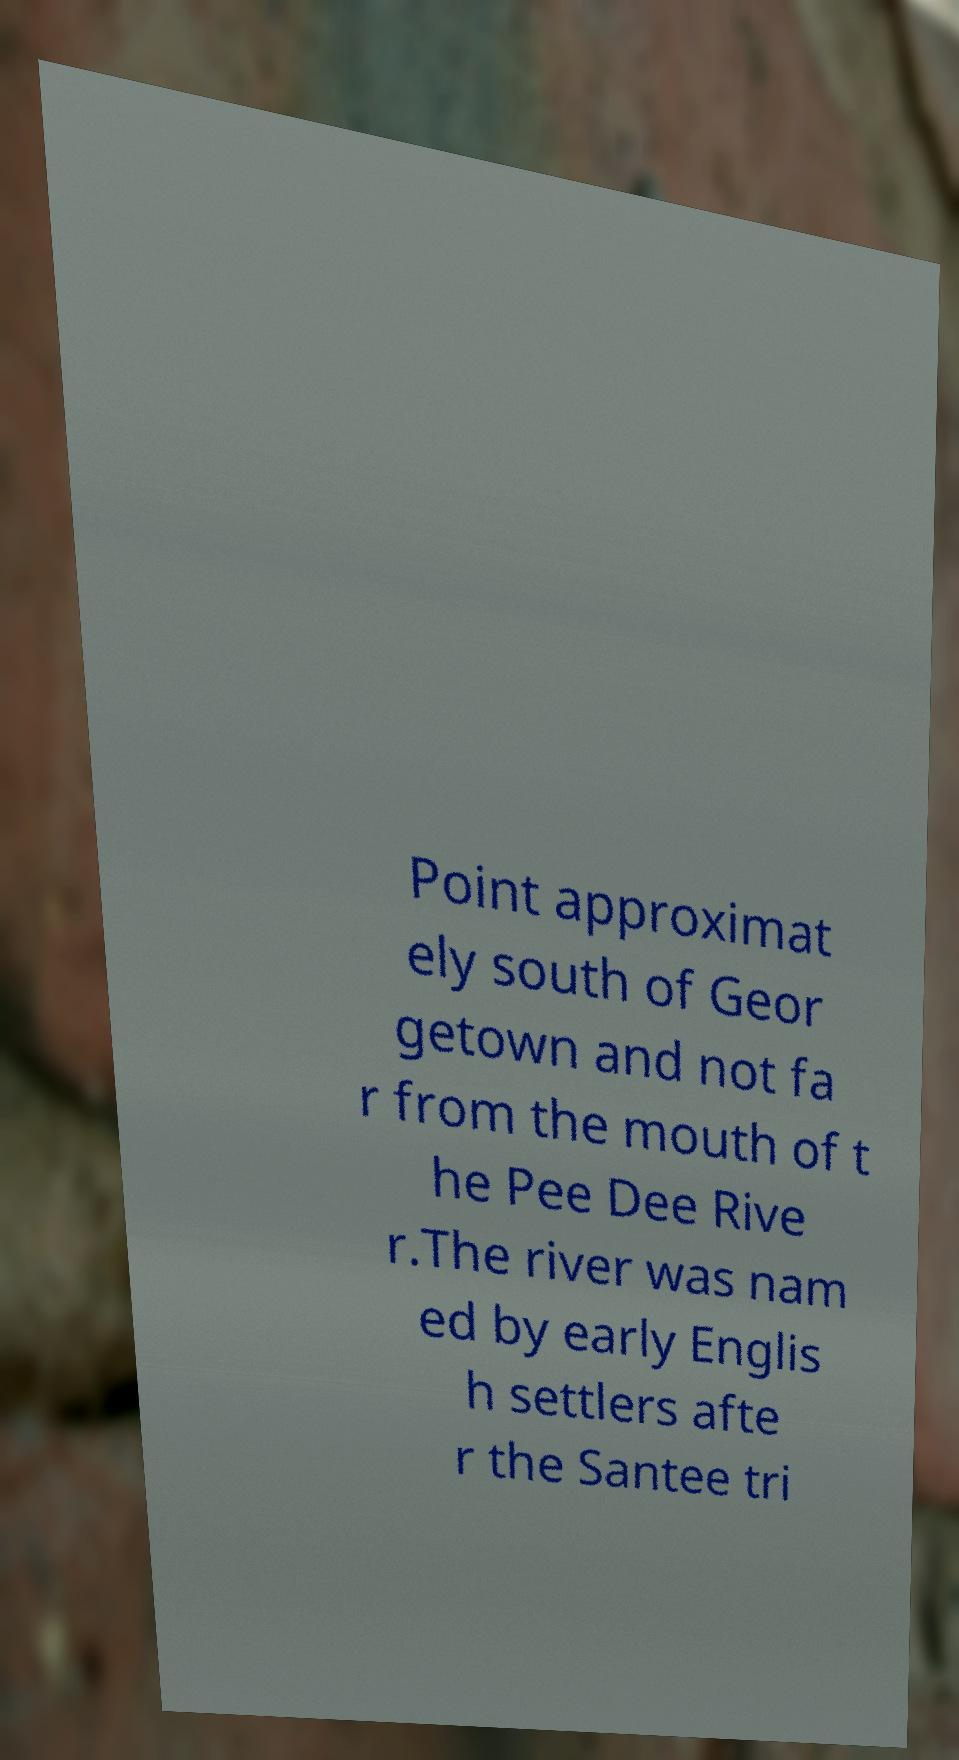I need the written content from this picture converted into text. Can you do that? Point approximat ely south of Geor getown and not fa r from the mouth of t he Pee Dee Rive r.The river was nam ed by early Englis h settlers afte r the Santee tri 